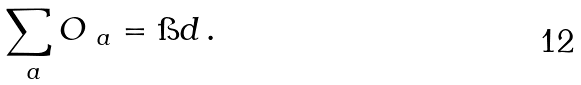Convert formula to latex. <formula><loc_0><loc_0><loc_500><loc_500>\sum _ { \ a } O _ { \ a } = \i d \, .</formula> 